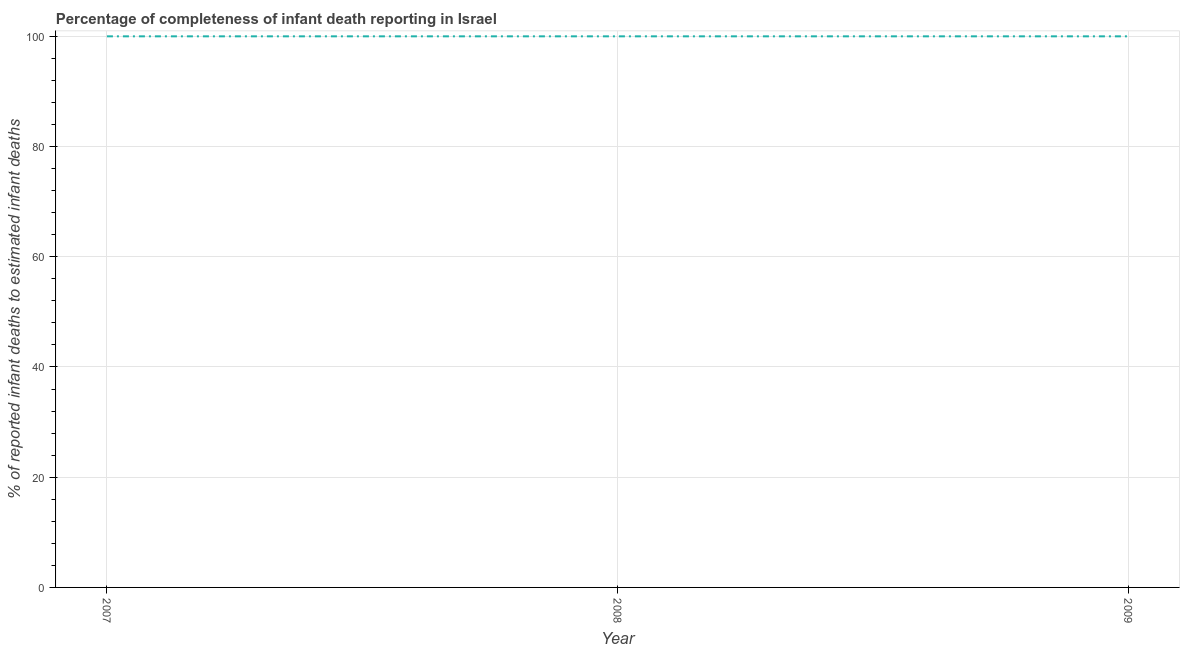What is the completeness of infant death reporting in 2007?
Your response must be concise. 100. Across all years, what is the maximum completeness of infant death reporting?
Offer a terse response. 100. Across all years, what is the minimum completeness of infant death reporting?
Keep it short and to the point. 100. In which year was the completeness of infant death reporting maximum?
Provide a short and direct response. 2007. What is the sum of the completeness of infant death reporting?
Give a very brief answer. 300. What is the average completeness of infant death reporting per year?
Your answer should be very brief. 100. In how many years, is the completeness of infant death reporting greater than 4 %?
Ensure brevity in your answer.  3. What is the ratio of the completeness of infant death reporting in 2008 to that in 2009?
Your answer should be very brief. 1. Is the difference between the completeness of infant death reporting in 2007 and 2009 greater than the difference between any two years?
Offer a very short reply. Yes. What is the difference between the highest and the second highest completeness of infant death reporting?
Give a very brief answer. 0. What is the difference between the highest and the lowest completeness of infant death reporting?
Provide a succinct answer. 0. In how many years, is the completeness of infant death reporting greater than the average completeness of infant death reporting taken over all years?
Keep it short and to the point. 0. Does the completeness of infant death reporting monotonically increase over the years?
Make the answer very short. No. How many lines are there?
Keep it short and to the point. 1. What is the difference between two consecutive major ticks on the Y-axis?
Your response must be concise. 20. What is the title of the graph?
Make the answer very short. Percentage of completeness of infant death reporting in Israel. What is the label or title of the Y-axis?
Keep it short and to the point. % of reported infant deaths to estimated infant deaths. What is the % of reported infant deaths to estimated infant deaths in 2008?
Provide a short and direct response. 100. What is the difference between the % of reported infant deaths to estimated infant deaths in 2007 and 2009?
Your answer should be compact. 0. What is the ratio of the % of reported infant deaths to estimated infant deaths in 2007 to that in 2008?
Your response must be concise. 1. What is the ratio of the % of reported infant deaths to estimated infant deaths in 2008 to that in 2009?
Offer a very short reply. 1. 